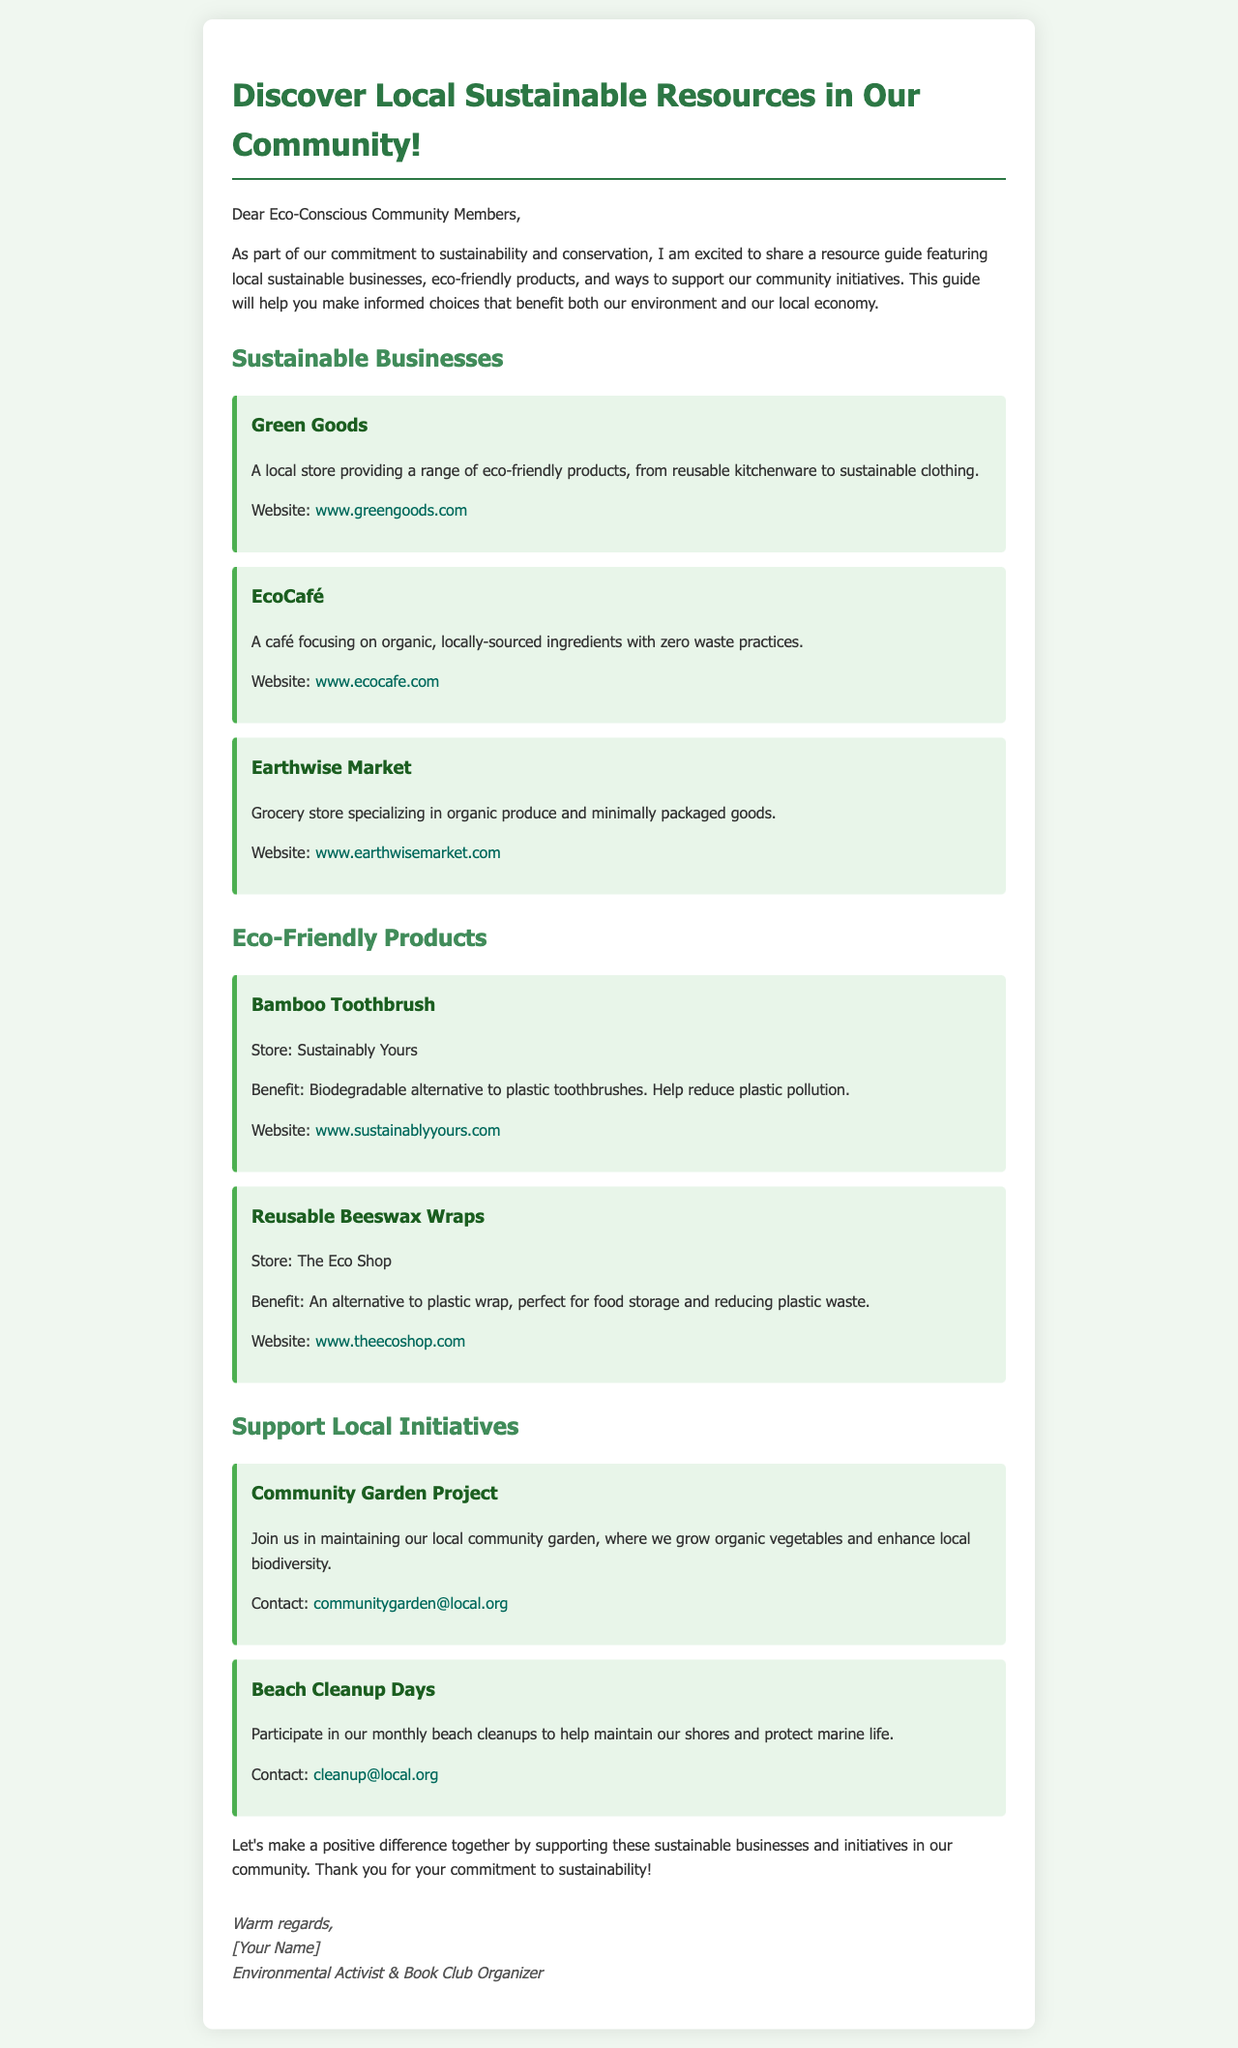What is the title of the document? The title is the main heading of the document that introduces the topic, which is "Discover Local Sustainable Resources".
Answer: Discover Local Sustainable Resources How many sustainable businesses are listed? The document lists three sustainable businesses under the "Sustainable Businesses" section.
Answer: 3 What is the first product mentioned in the eco-friendly products section? The first product listed is under the "Eco-Friendly Products" section and is a "Bamboo Toothbrush".
Answer: Bamboo Toothbrush What initiative focuses on maintaining a garden? The document provides information about the "Community Garden Project", which focuses on maintaining a garden.
Answer: Community Garden Project What is the contact email for beach cleanup? The document includes a specific email address for the beach cleanup initiative, which is provided under the "Beach Cleanup Days" section.
Answer: cleanup@local.org What type of products does Green Goods sell? The document describes Green Goods as a local store providing a range of eco-friendly products.
Answer: Eco-friendly products How does EcoCafé source its ingredients? The document specifies that EcoCafé focuses on organic, locally-sourced ingredients.
Answer: Locally-sourced ingredients What is the primary benefit of reusable beeswax wraps? The document states the benefit as being an alternative to plastic wrap, helping to reduce plastic waste.
Answer: Reducing plastic waste What color is the background of the document? The background color of the document is described as a light green shade, specifically "#f0f7f0".
Answer: #f0f7f0 